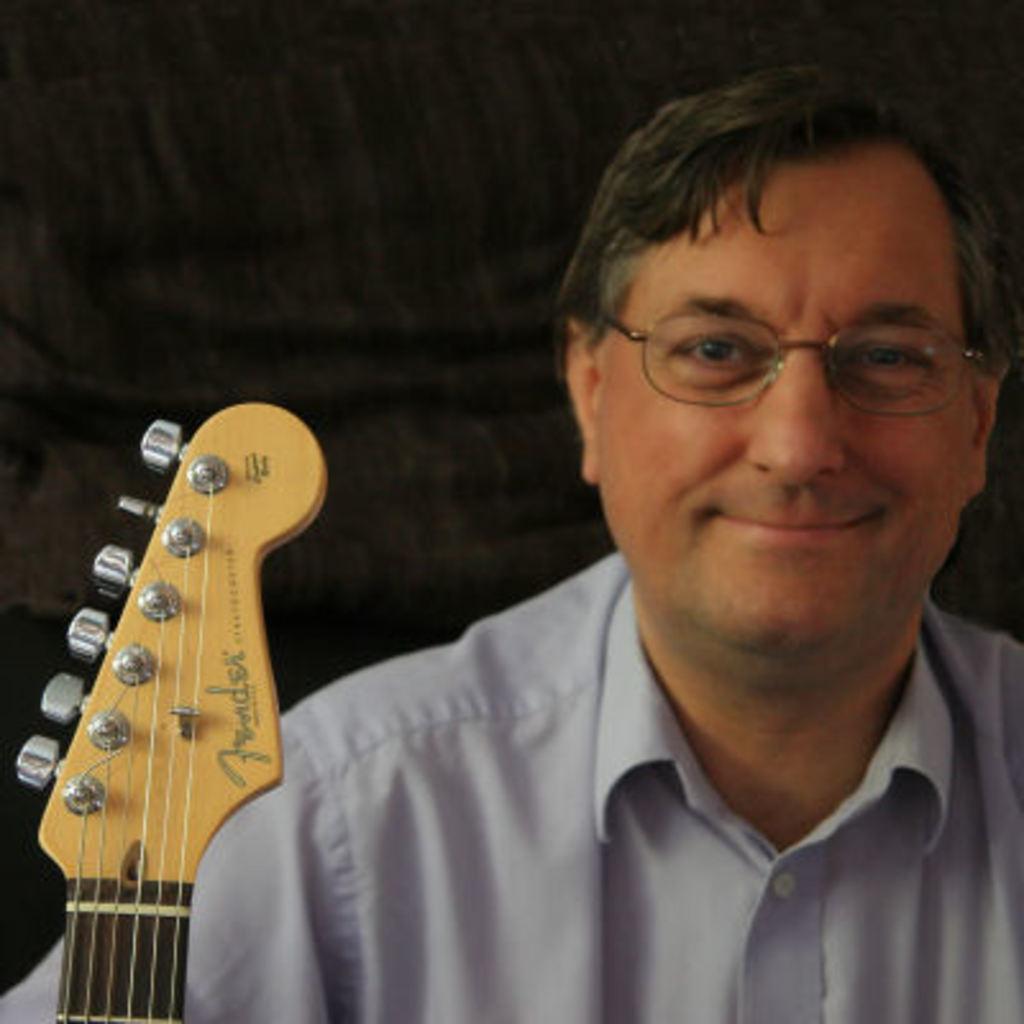In one or two sentences, can you explain what this image depicts? The man wearing a light blue shirt with a smiling face. There is a guitar in front of him. 